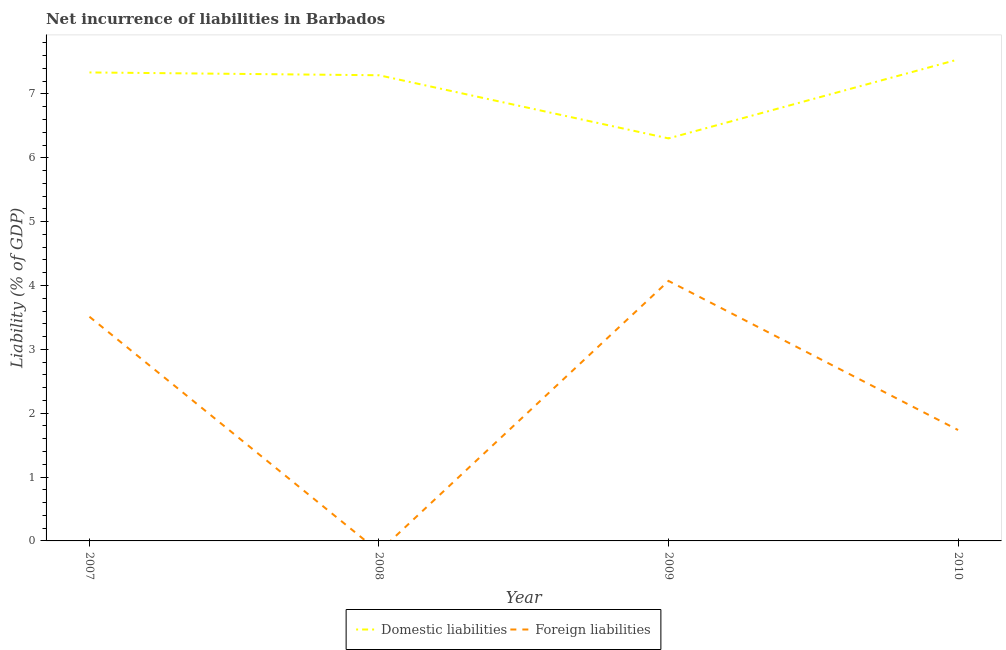Does the line corresponding to incurrence of domestic liabilities intersect with the line corresponding to incurrence of foreign liabilities?
Provide a short and direct response. No. Is the number of lines equal to the number of legend labels?
Keep it short and to the point. No. What is the incurrence of domestic liabilities in 2008?
Your answer should be very brief. 7.29. Across all years, what is the maximum incurrence of foreign liabilities?
Keep it short and to the point. 4.07. What is the total incurrence of domestic liabilities in the graph?
Offer a terse response. 28.48. What is the difference between the incurrence of domestic liabilities in 2008 and that in 2010?
Your response must be concise. -0.25. What is the difference between the incurrence of domestic liabilities in 2009 and the incurrence of foreign liabilities in 2008?
Keep it short and to the point. 6.3. What is the average incurrence of foreign liabilities per year?
Your response must be concise. 2.33. In the year 2009, what is the difference between the incurrence of foreign liabilities and incurrence of domestic liabilities?
Provide a short and direct response. -2.23. In how many years, is the incurrence of domestic liabilities greater than 3 %?
Your response must be concise. 4. What is the ratio of the incurrence of domestic liabilities in 2008 to that in 2009?
Offer a terse response. 1.16. Is the difference between the incurrence of domestic liabilities in 2007 and 2009 greater than the difference between the incurrence of foreign liabilities in 2007 and 2009?
Provide a succinct answer. Yes. What is the difference between the highest and the second highest incurrence of foreign liabilities?
Offer a terse response. 0.56. What is the difference between the highest and the lowest incurrence of foreign liabilities?
Your response must be concise. 4.07. Does the incurrence of domestic liabilities monotonically increase over the years?
Your answer should be very brief. No. Is the incurrence of foreign liabilities strictly greater than the incurrence of domestic liabilities over the years?
Make the answer very short. No. Is the incurrence of foreign liabilities strictly less than the incurrence of domestic liabilities over the years?
Keep it short and to the point. Yes. How many years are there in the graph?
Keep it short and to the point. 4. What is the difference between two consecutive major ticks on the Y-axis?
Ensure brevity in your answer.  1. Does the graph contain any zero values?
Your response must be concise. Yes. Does the graph contain grids?
Make the answer very short. No. Where does the legend appear in the graph?
Your response must be concise. Bottom center. How many legend labels are there?
Offer a terse response. 2. How are the legend labels stacked?
Provide a short and direct response. Horizontal. What is the title of the graph?
Ensure brevity in your answer.  Net incurrence of liabilities in Barbados. Does "Crop" appear as one of the legend labels in the graph?
Ensure brevity in your answer.  No. What is the label or title of the Y-axis?
Your response must be concise. Liability (% of GDP). What is the Liability (% of GDP) of Domestic liabilities in 2007?
Offer a very short reply. 7.34. What is the Liability (% of GDP) in Foreign liabilities in 2007?
Provide a succinct answer. 3.51. What is the Liability (% of GDP) of Domestic liabilities in 2008?
Make the answer very short. 7.29. What is the Liability (% of GDP) of Foreign liabilities in 2008?
Offer a terse response. 0. What is the Liability (% of GDP) in Domestic liabilities in 2009?
Provide a short and direct response. 6.3. What is the Liability (% of GDP) in Foreign liabilities in 2009?
Your answer should be very brief. 4.07. What is the Liability (% of GDP) in Domestic liabilities in 2010?
Your answer should be compact. 7.54. What is the Liability (% of GDP) in Foreign liabilities in 2010?
Provide a succinct answer. 1.74. Across all years, what is the maximum Liability (% of GDP) in Domestic liabilities?
Offer a very short reply. 7.54. Across all years, what is the maximum Liability (% of GDP) of Foreign liabilities?
Provide a short and direct response. 4.07. Across all years, what is the minimum Liability (% of GDP) of Domestic liabilities?
Your answer should be very brief. 6.3. Across all years, what is the minimum Liability (% of GDP) in Foreign liabilities?
Your answer should be very brief. 0. What is the total Liability (% of GDP) in Domestic liabilities in the graph?
Provide a succinct answer. 28.48. What is the total Liability (% of GDP) in Foreign liabilities in the graph?
Give a very brief answer. 9.32. What is the difference between the Liability (% of GDP) of Domestic liabilities in 2007 and that in 2008?
Your response must be concise. 0.04. What is the difference between the Liability (% of GDP) in Domestic liabilities in 2007 and that in 2009?
Ensure brevity in your answer.  1.03. What is the difference between the Liability (% of GDP) of Foreign liabilities in 2007 and that in 2009?
Keep it short and to the point. -0.56. What is the difference between the Liability (% of GDP) of Domestic liabilities in 2007 and that in 2010?
Ensure brevity in your answer.  -0.2. What is the difference between the Liability (% of GDP) of Foreign liabilities in 2007 and that in 2010?
Offer a terse response. 1.77. What is the difference between the Liability (% of GDP) in Domestic liabilities in 2008 and that in 2009?
Your answer should be very brief. 0.99. What is the difference between the Liability (% of GDP) in Domestic liabilities in 2008 and that in 2010?
Your answer should be compact. -0.25. What is the difference between the Liability (% of GDP) of Domestic liabilities in 2009 and that in 2010?
Keep it short and to the point. -1.24. What is the difference between the Liability (% of GDP) of Foreign liabilities in 2009 and that in 2010?
Your response must be concise. 2.33. What is the difference between the Liability (% of GDP) in Domestic liabilities in 2007 and the Liability (% of GDP) in Foreign liabilities in 2009?
Your response must be concise. 3.27. What is the difference between the Liability (% of GDP) of Domestic liabilities in 2007 and the Liability (% of GDP) of Foreign liabilities in 2010?
Ensure brevity in your answer.  5.6. What is the difference between the Liability (% of GDP) in Domestic liabilities in 2008 and the Liability (% of GDP) in Foreign liabilities in 2009?
Provide a succinct answer. 3.22. What is the difference between the Liability (% of GDP) in Domestic liabilities in 2008 and the Liability (% of GDP) in Foreign liabilities in 2010?
Provide a short and direct response. 5.56. What is the difference between the Liability (% of GDP) of Domestic liabilities in 2009 and the Liability (% of GDP) of Foreign liabilities in 2010?
Make the answer very short. 4.57. What is the average Liability (% of GDP) in Domestic liabilities per year?
Your answer should be compact. 7.12. What is the average Liability (% of GDP) of Foreign liabilities per year?
Provide a short and direct response. 2.33. In the year 2007, what is the difference between the Liability (% of GDP) of Domestic liabilities and Liability (% of GDP) of Foreign liabilities?
Ensure brevity in your answer.  3.83. In the year 2009, what is the difference between the Liability (% of GDP) in Domestic liabilities and Liability (% of GDP) in Foreign liabilities?
Make the answer very short. 2.23. In the year 2010, what is the difference between the Liability (% of GDP) of Domestic liabilities and Liability (% of GDP) of Foreign liabilities?
Provide a short and direct response. 5.8. What is the ratio of the Liability (% of GDP) of Domestic liabilities in 2007 to that in 2008?
Your answer should be compact. 1.01. What is the ratio of the Liability (% of GDP) of Domestic liabilities in 2007 to that in 2009?
Ensure brevity in your answer.  1.16. What is the ratio of the Liability (% of GDP) of Foreign liabilities in 2007 to that in 2009?
Give a very brief answer. 0.86. What is the ratio of the Liability (% of GDP) in Domestic liabilities in 2007 to that in 2010?
Offer a very short reply. 0.97. What is the ratio of the Liability (% of GDP) in Foreign liabilities in 2007 to that in 2010?
Offer a terse response. 2.02. What is the ratio of the Liability (% of GDP) in Domestic liabilities in 2008 to that in 2009?
Provide a succinct answer. 1.16. What is the ratio of the Liability (% of GDP) of Domestic liabilities in 2008 to that in 2010?
Your answer should be very brief. 0.97. What is the ratio of the Liability (% of GDP) of Domestic liabilities in 2009 to that in 2010?
Make the answer very short. 0.84. What is the ratio of the Liability (% of GDP) in Foreign liabilities in 2009 to that in 2010?
Provide a succinct answer. 2.34. What is the difference between the highest and the second highest Liability (% of GDP) in Domestic liabilities?
Offer a terse response. 0.2. What is the difference between the highest and the second highest Liability (% of GDP) of Foreign liabilities?
Offer a very short reply. 0.56. What is the difference between the highest and the lowest Liability (% of GDP) of Domestic liabilities?
Provide a short and direct response. 1.24. What is the difference between the highest and the lowest Liability (% of GDP) of Foreign liabilities?
Keep it short and to the point. 4.07. 